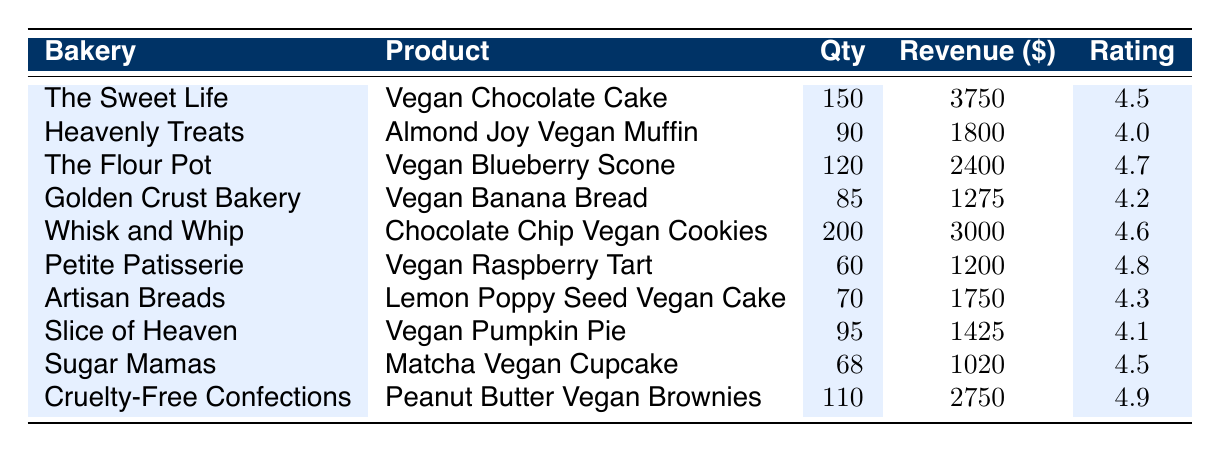What is the highest sales revenue among the vegan pastries? Looking at the revenue column, The Sweet Life had the highest sales revenue of $3750 from the Vegan Chocolate Cake.
Answer: $3750 Which vegan pastry received the highest customer feedback rating? By examining the ratings, the Peanut Butter Vegan Brownies from Cruelty-Free Confections received the highest rating of 4.9.
Answer: 4.9 How many quantities of Vegan Banana Bread were sold? The sales quantity for Vegan Banana Bread at Golden Crust Bakery is listed as 85.
Answer: 85 What is the total sales revenue for all vegan pastries combined? Adding the revenue values from each bakery: 3750 + 1800 + 2400 + 1275 + 3000 + 1200 + 1750 + 1425 + 1020 + 2750 =  19270.
Answer: $19,270 Is the sales quantity of the Vegan Pumpkin Pie higher than that of the Vegan Raspberry Tart? The Vegan Pumpkin Pie sold 95, while the Vegan Raspberry Tart sold 60, making the former higher.
Answer: Yes What is the average customer feedback rating for the vegan pastries? To calculate the average, sum the ratings (4.5 + 4.0 + 4.7 + 4.2 + 4.6 + 4.8 + 4.3 + 4.1 + 4.5 + 4.9 = 47.6) and divide by the number of products (10). The average is 47.6/10 = 4.76.
Answer: 4.76 Which bakery sold the most quantity of vegan pastries? Whisk and Whip sold the highest quantity at 200 for the Chocolate Chip Vegan Cookies.
Answer: 200 What are the names of the bakeries that sold products with a rating of 4.5 or higher? The bakers with ratings of 4.5 or higher are The Sweet Life, The Flour Pot, Whisk and Whip, Petite Patisserie, Sugar Mamas, and Cruelty-Free Confections.
Answer: The Sweet Life, The Flour Pot, Whisk and Whip, Petite Patisserie, Sugar Mamas, Cruelty-Free Confections How many more Vegan Blueberry Scones were sold than Vegan Banana Bread? Vegan Blueberry Scones sold 120, and Vegan Banana Bread sold 85. The difference is 120 - 85 = 35.
Answer: 35 What is the total sales quantity of pastries for The Sweet Life and Sugar Mamas? For The Sweet Life, the sales quantity is 150, and for Sugar Mamas, it is 68. The total is 150 + 68 = 218.
Answer: 218 